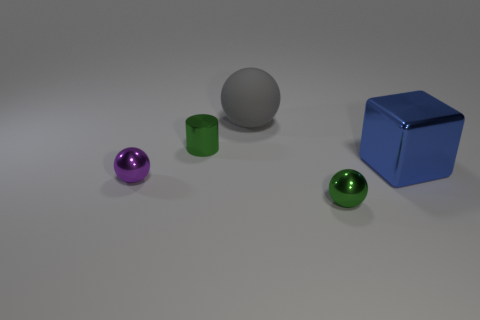Subtract all small metal balls. How many balls are left? 1 Add 2 big blue blocks. How many objects exist? 7 Subtract all spheres. How many objects are left? 2 Subtract 1 blocks. How many blocks are left? 0 Subtract all brown blocks. Subtract all brown balls. How many blocks are left? 1 Subtract all big gray spheres. Subtract all blocks. How many objects are left? 3 Add 1 big blue shiny cubes. How many big blue shiny cubes are left? 2 Add 1 big purple balls. How many big purple balls exist? 1 Subtract 1 green cylinders. How many objects are left? 4 